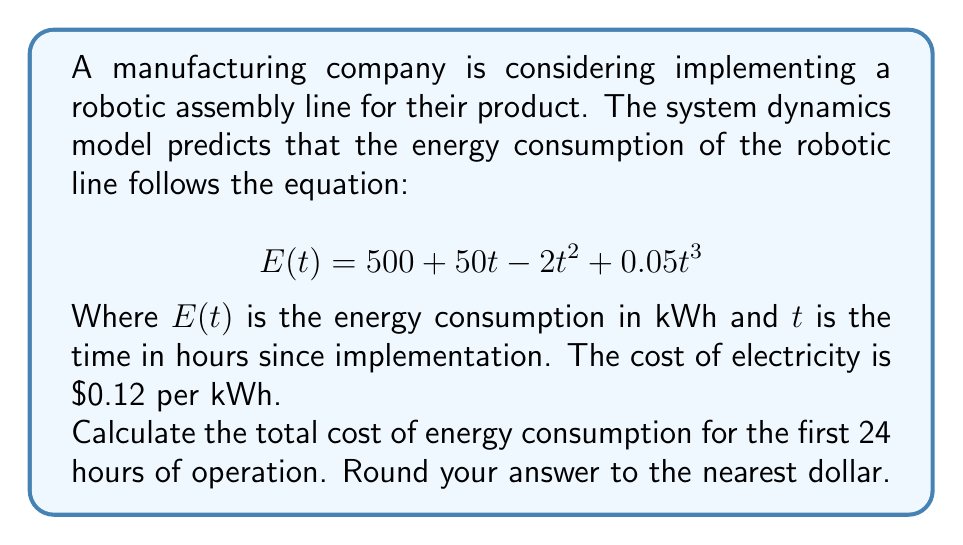Provide a solution to this math problem. To solve this problem, we need to follow these steps:

1) First, we need to find the total energy consumption over 24 hours. This requires integrating the energy consumption function from t = 0 to t = 24.

2) The integral of E(t) is:

   $$\int_0^{24} (500 + 50t - 2t^2 + 0.05t^3) dt$$

3) Solving this integral:

   $$[500t + 25t^2 - \frac{2}{3}t^3 + \frac{0.05}{4}t^4]_0^{24}$$

4) Evaluating at t = 24 and t = 0:

   $$(500(24) + 25(24^2) - \frac{2}{3}(24^3) + \frac{0.05}{4}(24^4)) - (0)$$

5) Simplifying:

   $$12000 + 14400 - 9216 + 6912 = 24096$$ kWh

6) Now that we have the total energy consumption, we multiply by the cost per kWh:

   $$24096 * $0.12 = $2891.52$$

7) Rounding to the nearest dollar:

   $$$2892$$
Answer: $2892 